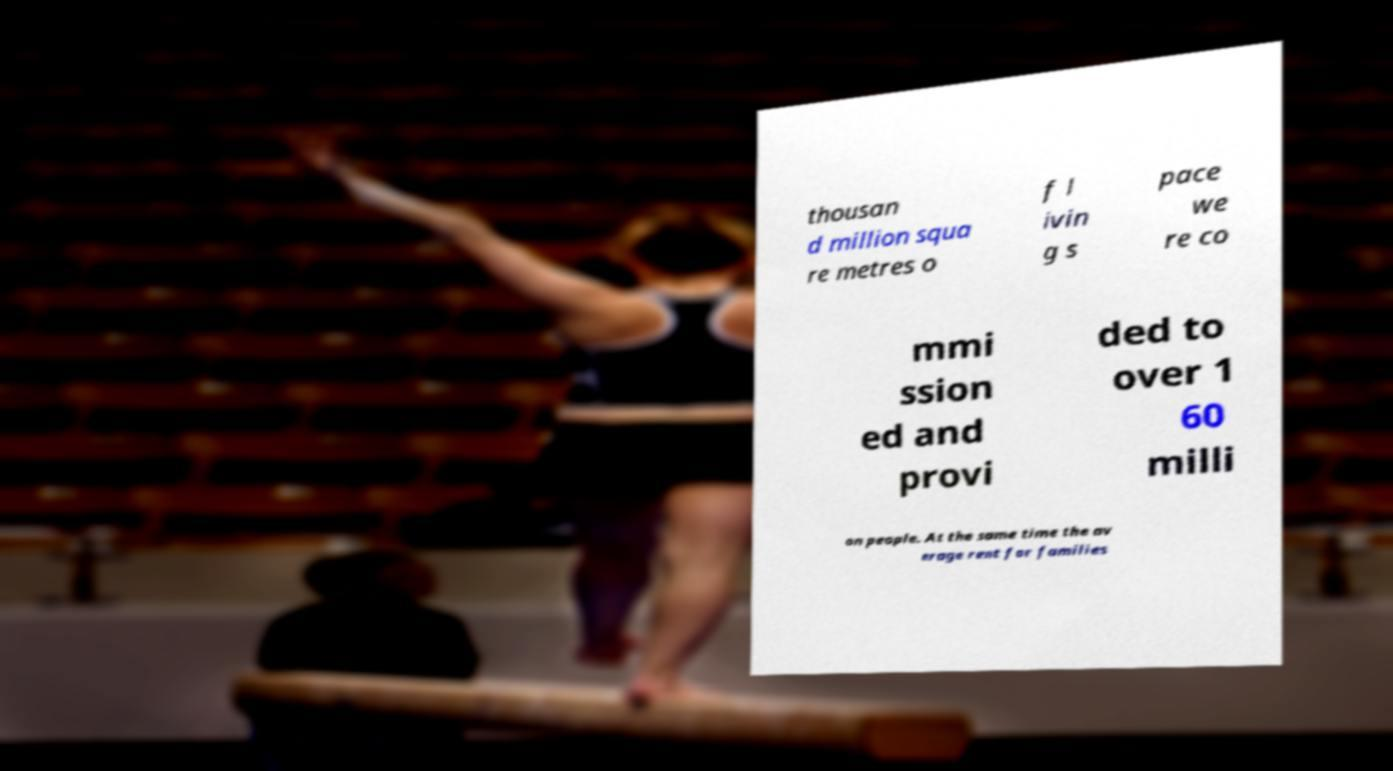There's text embedded in this image that I need extracted. Can you transcribe it verbatim? thousan d million squa re metres o f l ivin g s pace we re co mmi ssion ed and provi ded to over 1 60 milli on people. At the same time the av erage rent for families 